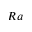Convert formula to latex. <formula><loc_0><loc_0><loc_500><loc_500>R a</formula> 